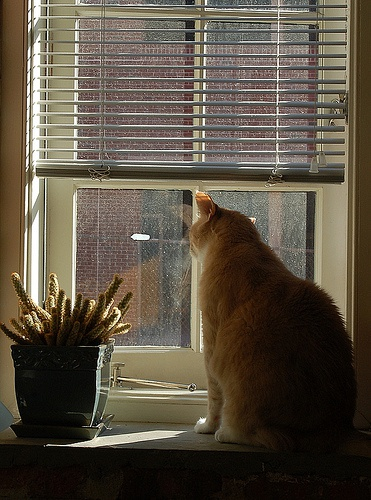Describe the objects in this image and their specific colors. I can see cat in black, maroon, and gray tones and potted plant in black, olive, maroon, and gray tones in this image. 